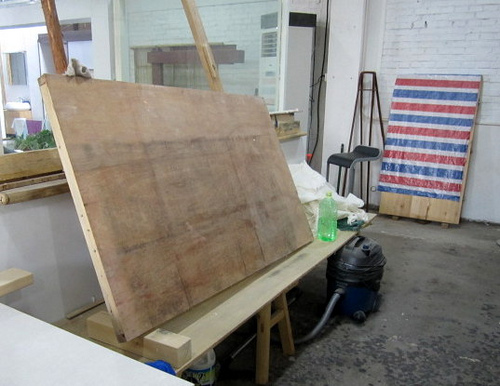<image>
Is there a vacuum under the bottle? Yes. The vacuum is positioned underneath the bottle, with the bottle above it in the vertical space. 